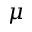<formula> <loc_0><loc_0><loc_500><loc_500>\mu</formula> 